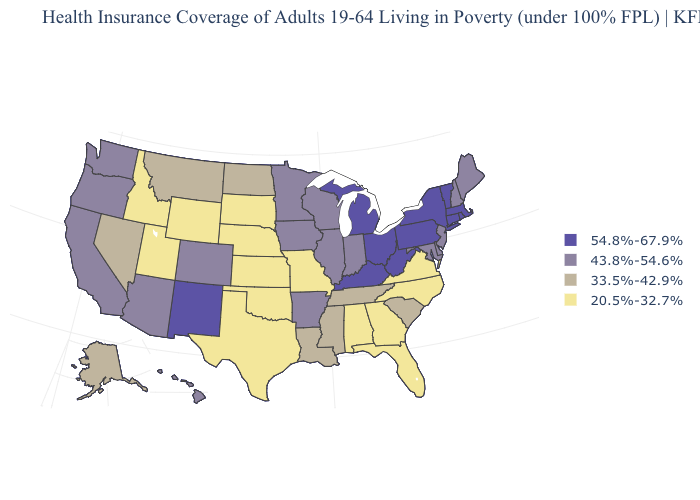What is the value of Colorado?
Quick response, please. 43.8%-54.6%. What is the value of Tennessee?
Give a very brief answer. 33.5%-42.9%. Name the states that have a value in the range 20.5%-32.7%?
Give a very brief answer. Alabama, Florida, Georgia, Idaho, Kansas, Missouri, Nebraska, North Carolina, Oklahoma, South Dakota, Texas, Utah, Virginia, Wyoming. Which states hav the highest value in the Northeast?
Short answer required. Connecticut, Massachusetts, New York, Pennsylvania, Rhode Island, Vermont. What is the value of Virginia?
Quick response, please. 20.5%-32.7%. Which states hav the highest value in the South?
Answer briefly. Kentucky, West Virginia. What is the value of West Virginia?
Quick response, please. 54.8%-67.9%. Which states hav the highest value in the South?
Concise answer only. Kentucky, West Virginia. Among the states that border Georgia , which have the highest value?
Answer briefly. South Carolina, Tennessee. Does Louisiana have a lower value than Minnesota?
Quick response, please. Yes. Name the states that have a value in the range 43.8%-54.6%?
Keep it brief. Arizona, Arkansas, California, Colorado, Delaware, Hawaii, Illinois, Indiana, Iowa, Maine, Maryland, Minnesota, New Hampshire, New Jersey, Oregon, Washington, Wisconsin. What is the highest value in the USA?
Write a very short answer. 54.8%-67.9%. Name the states that have a value in the range 54.8%-67.9%?
Short answer required. Connecticut, Kentucky, Massachusetts, Michigan, New Mexico, New York, Ohio, Pennsylvania, Rhode Island, Vermont, West Virginia. Does Mississippi have a lower value than West Virginia?
Write a very short answer. Yes. 